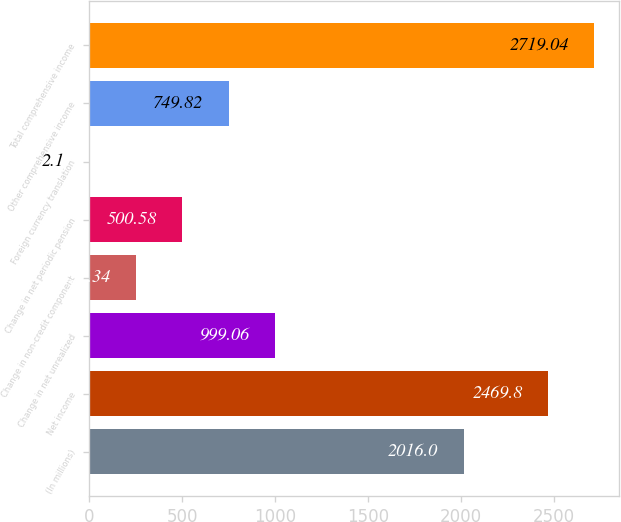<chart> <loc_0><loc_0><loc_500><loc_500><bar_chart><fcel>(In millions)<fcel>Net income<fcel>Change in net unrealized<fcel>Change in non-credit component<fcel>Change in net periodic pension<fcel>Foreign currency translation<fcel>Other comprehensive income<fcel>Total comprehensive income<nl><fcel>2016<fcel>2469.8<fcel>999.06<fcel>251.34<fcel>500.58<fcel>2.1<fcel>749.82<fcel>2719.04<nl></chart> 